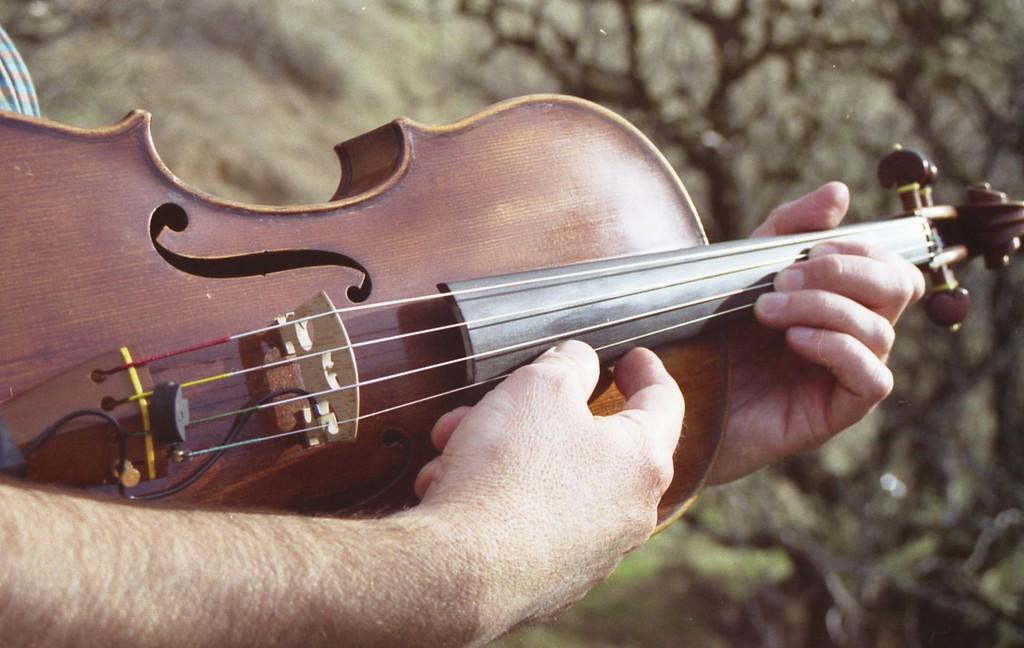Who is present in the image? There is a man in the image. What is the man holding in the image? The man is holding a violin. What can be seen in the background of the image? There are trees in the background of the image. What time is displayed on the clock in the image? There is no clock present in the image. 